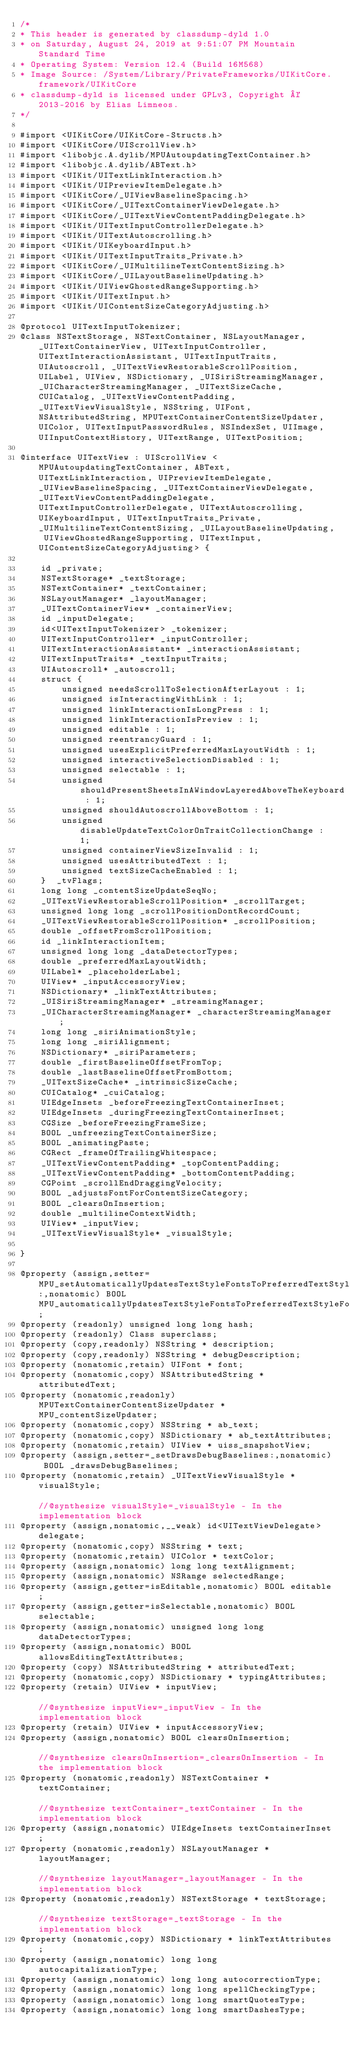<code> <loc_0><loc_0><loc_500><loc_500><_C_>/*
* This header is generated by classdump-dyld 1.0
* on Saturday, August 24, 2019 at 9:51:07 PM Mountain Standard Time
* Operating System: Version 12.4 (Build 16M568)
* Image Source: /System/Library/PrivateFrameworks/UIKitCore.framework/UIKitCore
* classdump-dyld is licensed under GPLv3, Copyright © 2013-2016 by Elias Limneos.
*/

#import <UIKitCore/UIKitCore-Structs.h>
#import <UIKitCore/UIScrollView.h>
#import <libobjc.A.dylib/MPUAutoupdatingTextContainer.h>
#import <libobjc.A.dylib/ABText.h>
#import <UIKit/UITextLinkInteraction.h>
#import <UIKit/UIPreviewItemDelegate.h>
#import <UIKitCore/_UIViewBaselineSpacing.h>
#import <UIKitCore/_UITextContainerViewDelegate.h>
#import <UIKitCore/_UITextViewContentPaddingDelegate.h>
#import <UIKit/UITextInputControllerDelegate.h>
#import <UIKit/UITextAutoscrolling.h>
#import <UIKit/UIKeyboardInput.h>
#import <UIKit/UITextInputTraits_Private.h>
#import <UIKitCore/_UIMultilineTextContentSizing.h>
#import <UIKitCore/_UILayoutBaselineUpdating.h>
#import <UIKit/UIViewGhostedRangeSupporting.h>
#import <UIKit/UITextInput.h>
#import <UIKit/UIContentSizeCategoryAdjusting.h>

@protocol UITextInputTokenizer;
@class NSTextStorage, NSTextContainer, NSLayoutManager, _UITextContainerView, UITextInputController, UITextInteractionAssistant, UITextInputTraits, UIAutoscroll, _UITextViewRestorableScrollPosition, UILabel, UIView, NSDictionary, _UISiriStreamingManager, _UICharacterStreamingManager, _UITextSizeCache, CUICatalog, _UITextViewContentPadding, _UITextViewVisualStyle, NSString, UIFont, NSAttributedString, MPUTextContainerContentSizeUpdater, UIColor, UITextInputPasswordRules, NSIndexSet, UIImage, UIInputContextHistory, UITextRange, UITextPosition;

@interface UITextView : UIScrollView <MPUAutoupdatingTextContainer, ABText, UITextLinkInteraction, UIPreviewItemDelegate, _UIViewBaselineSpacing, _UITextContainerViewDelegate, _UITextViewContentPaddingDelegate, UITextInputControllerDelegate, UITextAutoscrolling, UIKeyboardInput, UITextInputTraits_Private, _UIMultilineTextContentSizing, _UILayoutBaselineUpdating, UIViewGhostedRangeSupporting, UITextInput, UIContentSizeCategoryAdjusting> {

	id _private;
	NSTextStorage* _textStorage;
	NSTextContainer* _textContainer;
	NSLayoutManager* _layoutManager;
	_UITextContainerView* _containerView;
	id _inputDelegate;
	id<UITextInputTokenizer> _tokenizer;
	UITextInputController* _inputController;
	UITextInteractionAssistant* _interactionAssistant;
	UITextInputTraits* _textInputTraits;
	UIAutoscroll* _autoscroll;
	struct {
		unsigned needsScrollToSelectionAfterLayout : 1;
		unsigned isInteractingWithLink : 1;
		unsigned linkInteractionIsLongPress : 1;
		unsigned linkInteractionIsPreview : 1;
		unsigned editable : 1;
		unsigned reentrancyGuard : 1;
		unsigned usesExplicitPreferredMaxLayoutWidth : 1;
		unsigned interactiveSelectionDisabled : 1;
		unsigned selectable : 1;
		unsigned shouldPresentSheetsInAWindowLayeredAboveTheKeyboard : 1;
		unsigned shouldAutoscrollAboveBottom : 1;
		unsigned disableUpdateTextColorOnTraitCollectionChange : 1;
		unsigned containerViewSizeInvalid : 1;
		unsigned usesAttributedText : 1;
		unsigned textSizeCacheEnabled : 1;
	}  _tvFlags;
	long long _contentSizeUpdateSeqNo;
	_UITextViewRestorableScrollPosition* _scrollTarget;
	unsigned long long _scrollPositionDontRecordCount;
	_UITextViewRestorableScrollPosition* _scrollPosition;
	double _offsetFromScrollPosition;
	id _linkInteractionItem;
	unsigned long long _dataDetectorTypes;
	double _preferredMaxLayoutWidth;
	UILabel* _placeholderLabel;
	UIView* _inputAccessoryView;
	NSDictionary* _linkTextAttributes;
	_UISiriStreamingManager* _streamingManager;
	_UICharacterStreamingManager* _characterStreamingManager;
	long long _siriAnimationStyle;
	long long _siriAlignment;
	NSDictionary* _siriParameters;
	double _firstBaselineOffsetFromTop;
	double _lastBaselineOffsetFromBottom;
	_UITextSizeCache* _intrinsicSizeCache;
	CUICatalog* _cuiCatalog;
	UIEdgeInsets _beforeFreezingTextContainerInset;
	UIEdgeInsets _duringFreezingTextContainerInset;
	CGSize _beforeFreezingFrameSize;
	BOOL _unfreezingTextContainerSize;
	BOOL _animatingPaste;
	CGRect _frameOfTrailingWhitespace;
	_UITextViewContentPadding* _topContentPadding;
	_UITextViewContentPadding* _bottomContentPadding;
	CGPoint _scrollEndDraggingVelocity;
	BOOL _adjustsFontForContentSizeCategory;
	BOOL _clearsOnInsertion;
	double _multilineContextWidth;
	UIView* _inputView;
	_UITextViewVisualStyle* _visualStyle;

}

@property (assign,setter=MPU_setAutomaticallyUpdatesTextStyleFontsToPreferredTextStyleFonts:,nonatomic) BOOL MPU_automaticallyUpdatesTextStyleFontsToPreferredTextStyleFonts; 
@property (readonly) unsigned long long hash; 
@property (readonly) Class superclass; 
@property (copy,readonly) NSString * description; 
@property (copy,readonly) NSString * debugDescription; 
@property (nonatomic,retain) UIFont * font; 
@property (nonatomic,copy) NSAttributedString * attributedText; 
@property (nonatomic,readonly) MPUTextContainerContentSizeUpdater * MPU_contentSizeUpdater; 
@property (nonatomic,copy) NSString * ab_text; 
@property (nonatomic,copy) NSDictionary * ab_textAttributes; 
@property (nonatomic,retain) UIView * uiss_snapshotView; 
@property (assign,setter=_setDrawsDebugBaselines:,nonatomic) BOOL _drawsDebugBaselines; 
@property (nonatomic,retain) _UITextViewVisualStyle * visualStyle;                                                                                                                         //@synthesize visualStyle=_visualStyle - In the implementation block
@property (assign,nonatomic,__weak) id<UITextViewDelegate> delegate; 
@property (nonatomic,copy) NSString * text; 
@property (nonatomic,retain) UIColor * textColor; 
@property (assign,nonatomic) long long textAlignment; 
@property (assign,nonatomic) NSRange selectedRange; 
@property (assign,getter=isEditable,nonatomic) BOOL editable; 
@property (assign,getter=isSelectable,nonatomic) BOOL selectable; 
@property (assign,nonatomic) unsigned long long dataDetectorTypes; 
@property (assign,nonatomic) BOOL allowsEditingTextAttributes; 
@property (copy) NSAttributedString * attributedText; 
@property (nonatomic,copy) NSDictionary * typingAttributes; 
@property (retain) UIView * inputView;                                                                                                                                                     //@synthesize inputView=_inputView - In the implementation block
@property (retain) UIView * inputAccessoryView; 
@property (assign,nonatomic) BOOL clearsOnInsertion;                                                                                                                                       //@synthesize clearsOnInsertion=_clearsOnInsertion - In the implementation block
@property (nonatomic,readonly) NSTextContainer * textContainer;                                                                                                                            //@synthesize textContainer=_textContainer - In the implementation block
@property (assign,nonatomic) UIEdgeInsets textContainerInset; 
@property (nonatomic,readonly) NSLayoutManager * layoutManager;                                                                                                                            //@synthesize layoutManager=_layoutManager - In the implementation block
@property (nonatomic,readonly) NSTextStorage * textStorage;                                                                                                                                //@synthesize textStorage=_textStorage - In the implementation block
@property (nonatomic,copy) NSDictionary * linkTextAttributes; 
@property (assign,nonatomic) long long autocapitalizationType; 
@property (assign,nonatomic) long long autocorrectionType; 
@property (assign,nonatomic) long long spellCheckingType; 
@property (assign,nonatomic) long long smartQuotesType; 
@property (assign,nonatomic) long long smartDashesType; </code> 